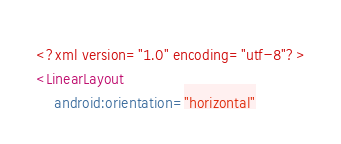Convert code to text. <code><loc_0><loc_0><loc_500><loc_500><_XML_><?xml version="1.0" encoding="utf-8"?>
<LinearLayout
    android:orientation="horizontal"</code> 